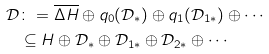Convert formula to latex. <formula><loc_0><loc_0><loc_500><loc_500>\mathcal { D } & \colon = \overline { \Delta H } \oplus q _ { 0 } ( \mathcal { D } _ { \ast } ) \oplus q _ { 1 } ( \mathcal { D } _ { 1 \ast } ) \oplus \cdots \\ & \subseteq H \oplus \mathcal { D } _ { \ast } \oplus \mathcal { D } _ { 1 \ast } \oplus \mathcal { D } _ { 2 \ast } \oplus \cdots</formula> 